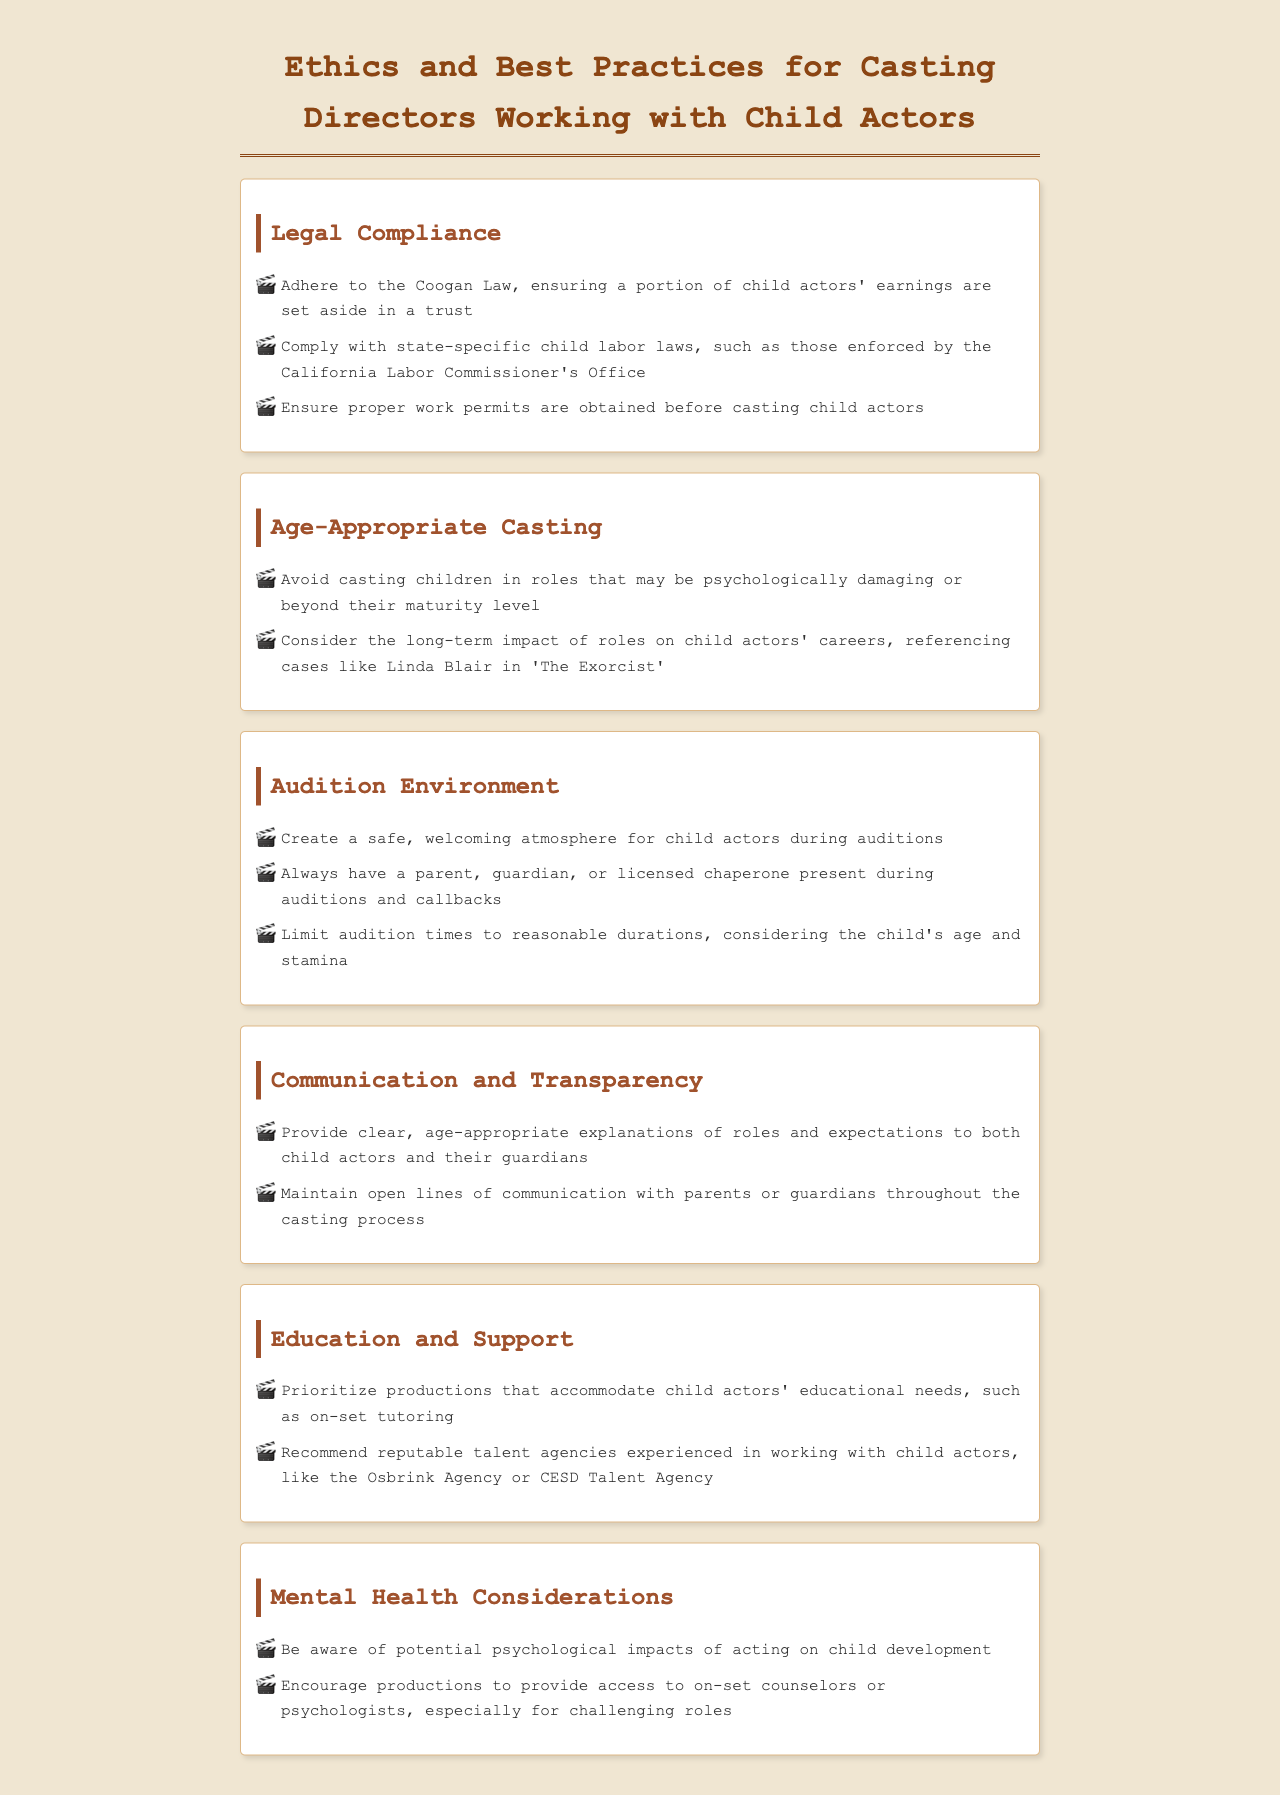What is the Coogan Law? The Coogan Law ensures that a portion of child actors' earnings are set aside in a trust.
Answer: A portion of earnings is set aside in a trust What should be obtained before casting child actors? Casting directors are required to obtain proper work permits before casting child actors.
Answer: Proper work permits What is an important consideration when casting children? An important consideration is to avoid casting children in roles that may be psychologically damaging or beyond their maturity level.
Answer: Psychologically damaging roles What is recommended for productions to support child education? Productions should accommodate child actors' educational needs, such as on-set tutoring.
Answer: On-set tutoring Why should there be a parent or guardian present during auditions? It ensures the safety and well-being of child actors during the audition process.
Answer: Safety and well-being What should casting directors provide about roles to child actors? Casting directors should provide clear, age-appropriate explanations of roles and expectations.
Answer: Clear, age-appropriate explanations What example is referenced in the document regarding long-term impacts on careers? The document references Linda Blair in 'The Exorcist' as an example.
Answer: Linda Blair in 'The Exorcist' What type of professionals should be accessible on set for challenging roles? Access to on-set counselors or psychologists should be provided, especially for challenging roles.
Answer: On-set counselors or psychologists 